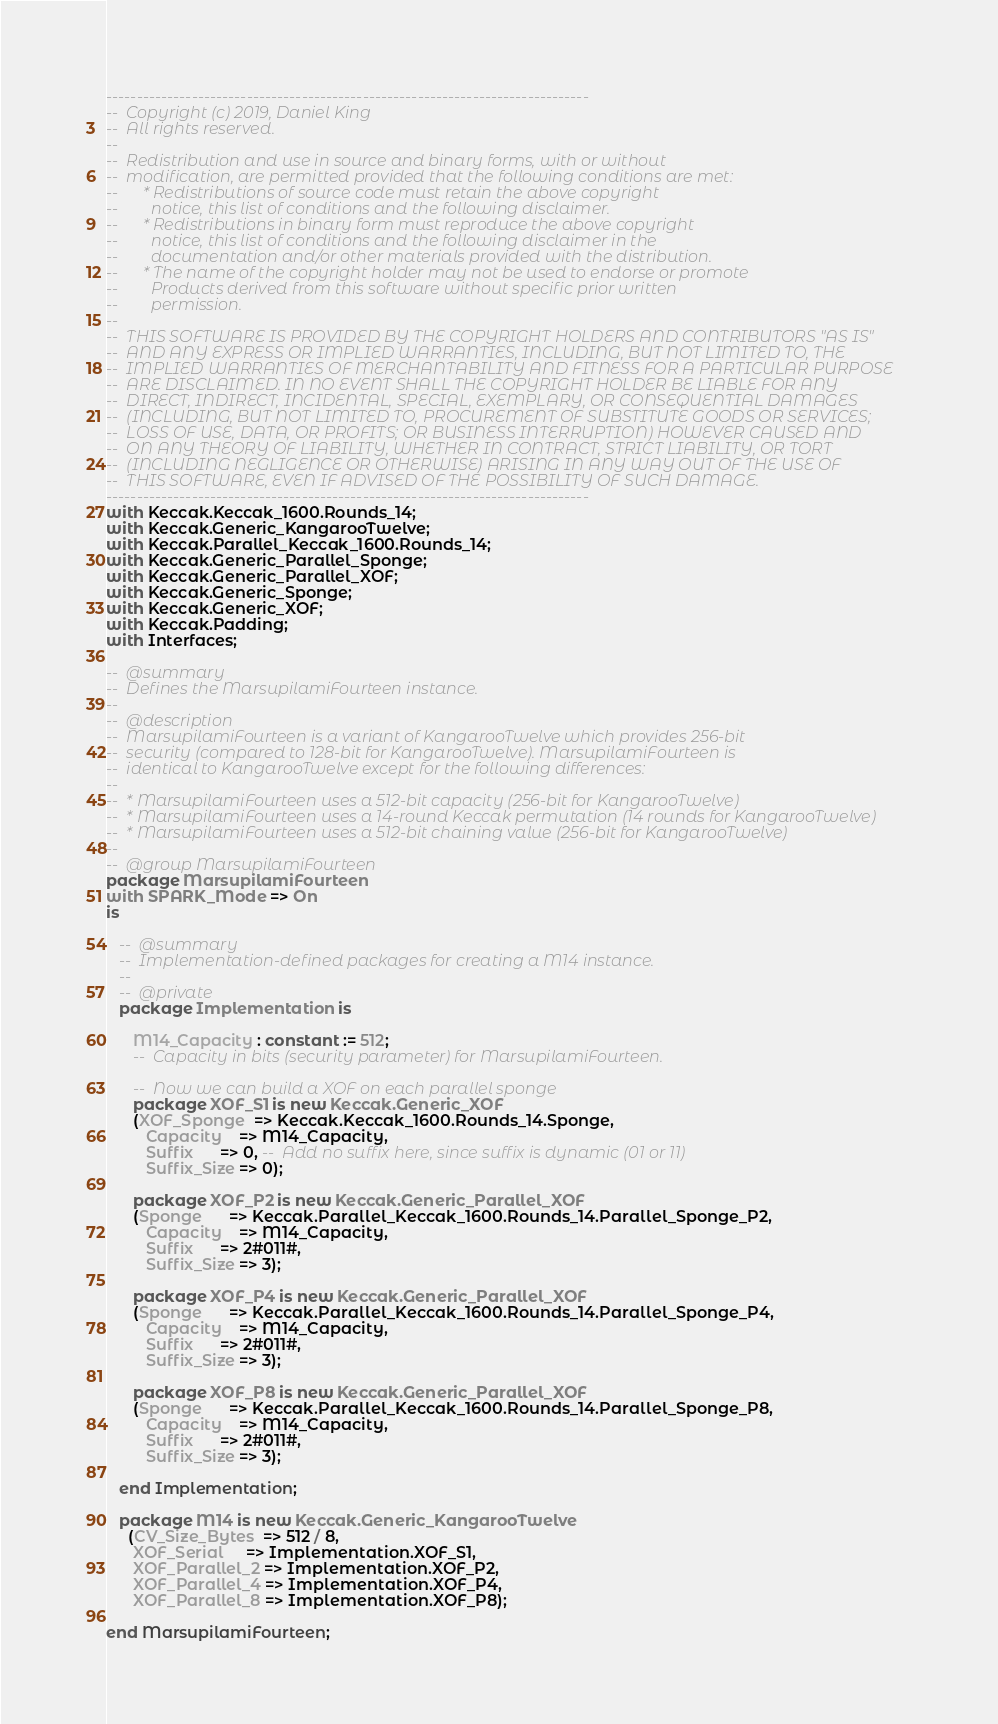Convert code to text. <code><loc_0><loc_0><loc_500><loc_500><_Ada_>-------------------------------------------------------------------------------
--  Copyright (c) 2019, Daniel King
--  All rights reserved.
--
--  Redistribution and use in source and binary forms, with or without
--  modification, are permitted provided that the following conditions are met:
--      * Redistributions of source code must retain the above copyright
--        notice, this list of conditions and the following disclaimer.
--      * Redistributions in binary form must reproduce the above copyright
--        notice, this list of conditions and the following disclaimer in the
--        documentation and/or other materials provided with the distribution.
--      * The name of the copyright holder may not be used to endorse or promote
--        Products derived from this software without specific prior written
--        permission.
--
--  THIS SOFTWARE IS PROVIDED BY THE COPYRIGHT HOLDERS AND CONTRIBUTORS "AS IS"
--  AND ANY EXPRESS OR IMPLIED WARRANTIES, INCLUDING, BUT NOT LIMITED TO, THE
--  IMPLIED WARRANTIES OF MERCHANTABILITY AND FITNESS FOR A PARTICULAR PURPOSE
--  ARE DISCLAIMED. IN NO EVENT SHALL THE COPYRIGHT HOLDER BE LIABLE FOR ANY
--  DIRECT, INDIRECT, INCIDENTAL, SPECIAL, EXEMPLARY, OR CONSEQUENTIAL DAMAGES
--  (INCLUDING, BUT NOT LIMITED TO, PROCUREMENT OF SUBSTITUTE GOODS OR SERVICES;
--  LOSS OF USE, DATA, OR PROFITS; OR BUSINESS INTERRUPTION) HOWEVER CAUSED AND
--  ON ANY THEORY OF LIABILITY, WHETHER IN CONTRACT, STRICT LIABILITY, OR TORT
--  (INCLUDING NEGLIGENCE OR OTHERWISE) ARISING IN ANY WAY OUT OF THE USE OF
--  THIS SOFTWARE, EVEN IF ADVISED OF THE POSSIBILITY OF SUCH DAMAGE.
-------------------------------------------------------------------------------
with Keccak.Keccak_1600.Rounds_14;
with Keccak.Generic_KangarooTwelve;
with Keccak.Parallel_Keccak_1600.Rounds_14;
with Keccak.Generic_Parallel_Sponge;
with Keccak.Generic_Parallel_XOF;
with Keccak.Generic_Sponge;
with Keccak.Generic_XOF;
with Keccak.Padding;
with Interfaces;

--  @summary
--  Defines the MarsupilamiFourteen instance.
--
--  @description
--  MarsupilamiFourteen is a variant of KangarooTwelve which provides 256-bit
--  security (compared to 128-bit for KangarooTwelve). MarsupilamiFourteen is
--  identical to KangarooTwelve except for the following differences:
--
--  * MarsupilamiFourteen uses a 512-bit capacity (256-bit for KangarooTwelve)
--  * MarsupilamiFourteen uses a 14-round Keccak permutation (14 rounds for KangarooTwelve)
--  * MarsupilamiFourteen uses a 512-bit chaining value (256-bit for KangarooTwelve)
--
--  @group MarsupilamiFourteen
package MarsupilamiFourteen
with SPARK_Mode => On
is

   --  @summary
   --  Implementation-defined packages for creating a M14 instance.
   --
   --  @private
   package Implementation is

      M14_Capacity : constant := 512;
      --  Capacity in bits (security parameter) for MarsupilamiFourteen.

      --  Now we can build a XOF on each parallel sponge
      package XOF_S1 is new Keccak.Generic_XOF
      (XOF_Sponge  => Keccak.Keccak_1600.Rounds_14.Sponge,
         Capacity    => M14_Capacity,
         Suffix      => 0, --  Add no suffix here, since suffix is dynamic (01 or 11)
         Suffix_Size => 0);

      package XOF_P2 is new Keccak.Generic_Parallel_XOF
      (Sponge      => Keccak.Parallel_Keccak_1600.Rounds_14.Parallel_Sponge_P2,
         Capacity    => M14_Capacity,
         Suffix      => 2#011#,
         Suffix_Size => 3);

      package XOF_P4 is new Keccak.Generic_Parallel_XOF
      (Sponge      => Keccak.Parallel_Keccak_1600.Rounds_14.Parallel_Sponge_P4,
         Capacity    => M14_Capacity,
         Suffix      => 2#011#,
         Suffix_Size => 3);

      package XOF_P8 is new Keccak.Generic_Parallel_XOF
      (Sponge      => Keccak.Parallel_Keccak_1600.Rounds_14.Parallel_Sponge_P8,
         Capacity    => M14_Capacity,
         Suffix      => 2#011#,
         Suffix_Size => 3);

   end Implementation;

   package M14 is new Keccak.Generic_KangarooTwelve
     (CV_Size_Bytes  => 512 / 8,
      XOF_Serial     => Implementation.XOF_S1,
      XOF_Parallel_2 => Implementation.XOF_P2,
      XOF_Parallel_4 => Implementation.XOF_P4,
      XOF_Parallel_8 => Implementation.XOF_P8);

end MarsupilamiFourteen;
</code> 